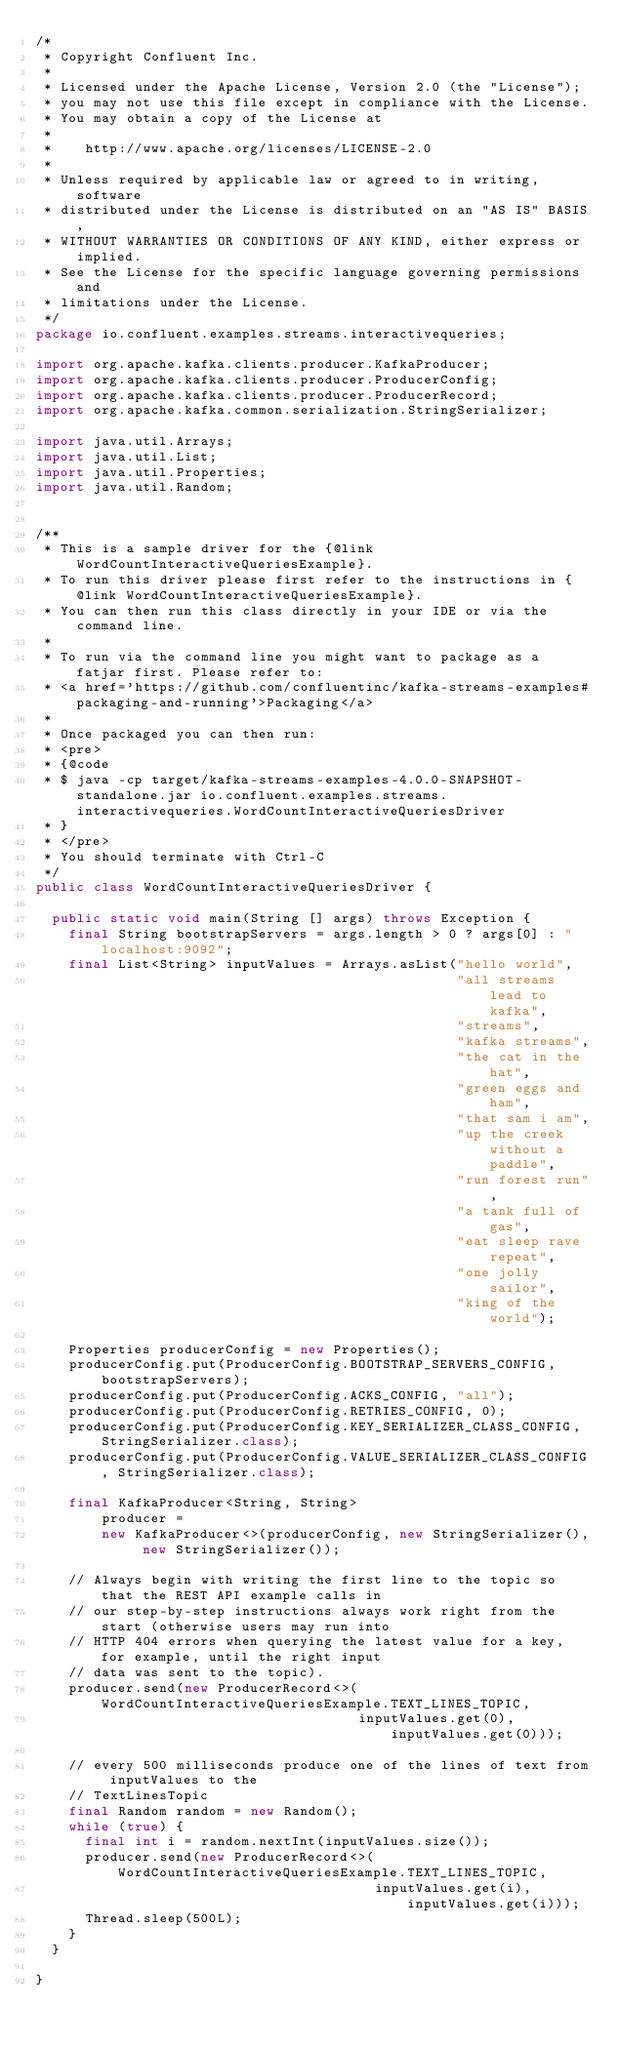<code> <loc_0><loc_0><loc_500><loc_500><_Java_>/*
 * Copyright Confluent Inc.
 *
 * Licensed under the Apache License, Version 2.0 (the "License");
 * you may not use this file except in compliance with the License.
 * You may obtain a copy of the License at
 *
 *    http://www.apache.org/licenses/LICENSE-2.0
 *
 * Unless required by applicable law or agreed to in writing, software
 * distributed under the License is distributed on an "AS IS" BASIS,
 * WITHOUT WARRANTIES OR CONDITIONS OF ANY KIND, either express or implied.
 * See the License for the specific language governing permissions and
 * limitations under the License.
 */
package io.confluent.examples.streams.interactivequeries;

import org.apache.kafka.clients.producer.KafkaProducer;
import org.apache.kafka.clients.producer.ProducerConfig;
import org.apache.kafka.clients.producer.ProducerRecord;
import org.apache.kafka.common.serialization.StringSerializer;

import java.util.Arrays;
import java.util.List;
import java.util.Properties;
import java.util.Random;


/**
 * This is a sample driver for the {@link WordCountInteractiveQueriesExample}.
 * To run this driver please first refer to the instructions in {@link WordCountInteractiveQueriesExample}.
 * You can then run this class directly in your IDE or via the command line.
 *
 * To run via the command line you might want to package as a fatjar first. Please refer to:
 * <a href='https://github.com/confluentinc/kafka-streams-examples#packaging-and-running'>Packaging</a>
 *
 * Once packaged you can then run:
 * <pre>
 * {@code
 * $ java -cp target/kafka-streams-examples-4.0.0-SNAPSHOT-standalone.jar io.confluent.examples.streams.interactivequeries.WordCountInteractiveQueriesDriver
 * }
 * </pre>
 * You should terminate with Ctrl-C
 */
public class WordCountInteractiveQueriesDriver {

  public static void main(String [] args) throws Exception {
    final String bootstrapServers = args.length > 0 ? args[0] : "localhost:9092";
    final List<String> inputValues = Arrays.asList("hello world",
                                                   "all streams lead to kafka",
                                                   "streams",
                                                   "kafka streams",
                                                   "the cat in the hat",
                                                   "green eggs and ham",
                                                   "that sam i am",
                                                   "up the creek without a paddle",
                                                   "run forest run",
                                                   "a tank full of gas",
                                                   "eat sleep rave repeat",
                                                   "one jolly sailor",
                                                   "king of the world");

    Properties producerConfig = new Properties();
    producerConfig.put(ProducerConfig.BOOTSTRAP_SERVERS_CONFIG, bootstrapServers);
    producerConfig.put(ProducerConfig.ACKS_CONFIG, "all");
    producerConfig.put(ProducerConfig.RETRIES_CONFIG, 0);
    producerConfig.put(ProducerConfig.KEY_SERIALIZER_CLASS_CONFIG, StringSerializer.class);
    producerConfig.put(ProducerConfig.VALUE_SERIALIZER_CLASS_CONFIG, StringSerializer.class);

    final KafkaProducer<String, String>
        producer =
        new KafkaProducer<>(producerConfig, new StringSerializer(), new StringSerializer());

    // Always begin with writing the first line to the topic so that the REST API example calls in
    // our step-by-step instructions always work right from the start (otherwise users may run into
    // HTTP 404 errors when querying the latest value for a key, for example, until the right input
    // data was sent to the topic).
    producer.send(new ProducerRecord<>(WordCountInteractiveQueriesExample.TEXT_LINES_TOPIC,
                                       inputValues.get(0), inputValues.get(0)));

    // every 500 milliseconds produce one of the lines of text from inputValues to the
    // TextLinesTopic
    final Random random = new Random();
    while (true) {
      final int i = random.nextInt(inputValues.size());
      producer.send(new ProducerRecord<>(WordCountInteractiveQueriesExample.TEXT_LINES_TOPIC,
                                         inputValues.get(i), inputValues.get(i)));
      Thread.sleep(500L);
    }
  }

}
</code> 